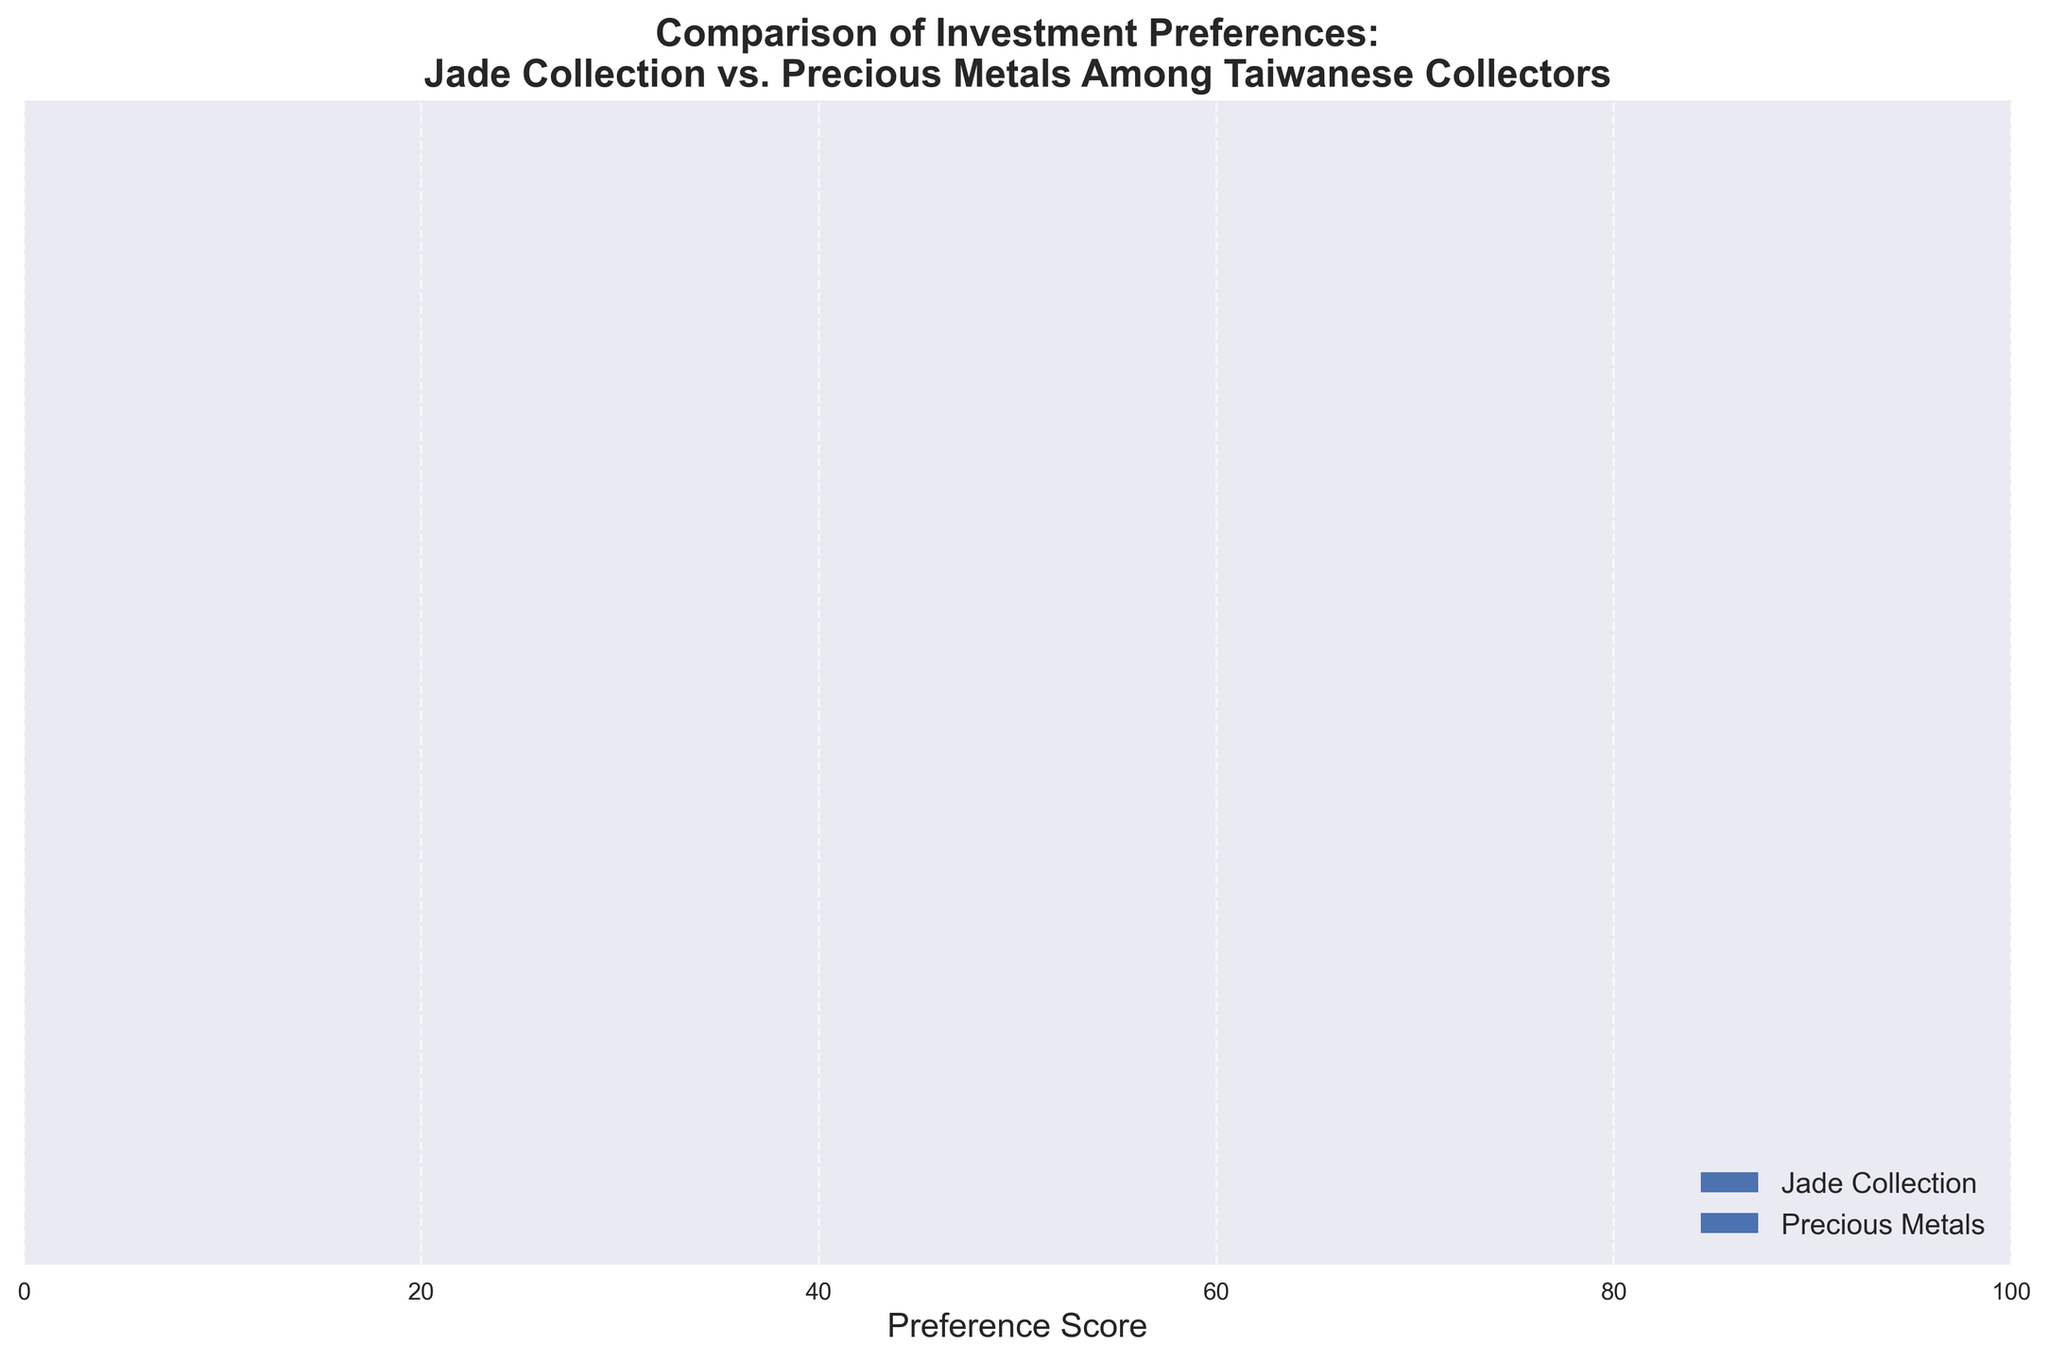What's the highest preference score among all categories for Jade Collection? Look at the Jade Collection bars and find the highest value. Jade Quality is 85, Historical Significance is 90, Cultural Value is 80, Aesthetic Appeal is 75, and Market Demand is 70. The highest value is 90 for Historical Significance.
Answer: 90 Which investment type has a higher preference score for Market Demand? Compare the bars for Market Demand in both investment types. Jade Collection's Market Demand score is 70, while Precious Metals' Market Value score (proxy for Market Demand) is 90. Precious Metals has a higher score.
Answer: Precious Metals What is the total preference score for Precious Metals across all categories? Sum the scores for Precious Metals: Gold Purity (80), Silver Purity (65), Market Value (90), Investment Security (85), and Market Liquidity (95). 80 + 65 + 90 + 85 + 95 = 415.
Answer: 415 Which category shows the smallest difference in preference scores between Jade Collection and Precious Metals? Calculate the differences: Jade Quality vs. Gold Purity is 85 - 80 = 5, Historical Significance vs. Silver Purity is 90 - 65 = 25, Cultural Value vs. Market Value is 80 - 90 = 10, Aesthetic Appeal vs. Investment Security is 75 - 85 = 10, Market Demand vs. Market Liquidity is 70 - 95 = 25. The smallest difference is 5.
Answer: Jade Quality vs. Gold Purity For which category do Jade Collection and Precious Metals have equal preference scores? Look at pairs to see if any scores match. From the chart, none of the categories between Jade Collection and Precious Metals have equal preference scores: 85 ≠ 80, 90 ≠ 65, 80 ≠ 90, 75 ≠ 85, 70 ≠ 95.
Answer: None What is the average preference score for all categories in Jade Collection? Sum all scores in Jade Collection and divide by the number of categories: (85 + 90 + 80 + 75 + 70) / 5 = 400 / 5 = 80.
Answer: 80 Which category in Jade Collection has the lowest preference score? Look at the Jade Collection categories and identify the smallest value: Jade Quality (85), Historical Significance (90), Cultural Value (80), Aesthetic Appeal (75), Market Demand (70). The lowest value is 70 in Market Demand.
Answer: Market Demand 